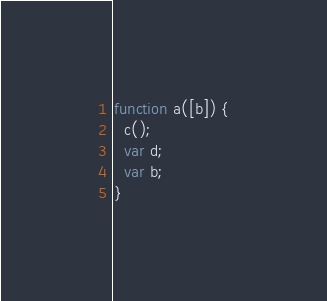<code> <loc_0><loc_0><loc_500><loc_500><_JavaScript_>function a([b]) {
  c();
  var d;
  var b;
}
</code> 